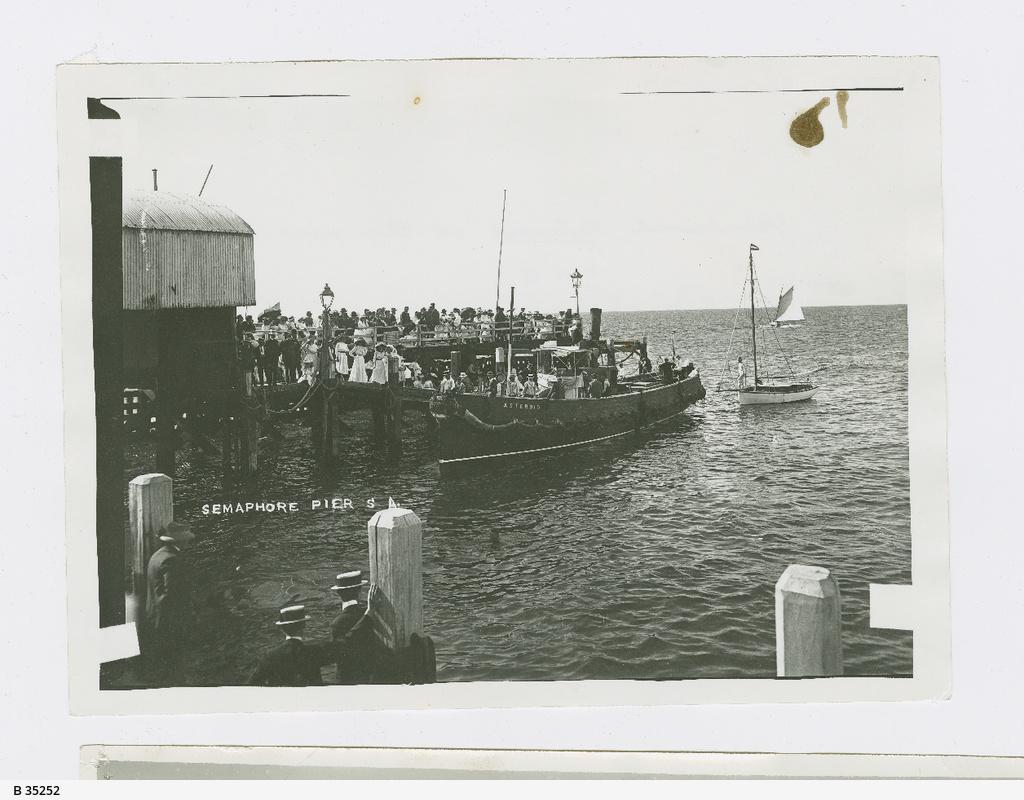Can you describe this image briefly? In the image we can see a picture, in the picture we can see some water. Above the water we can see some ships, in the ships few people are there. In the bottom left corner of the image few people are standing and there are some poles. 